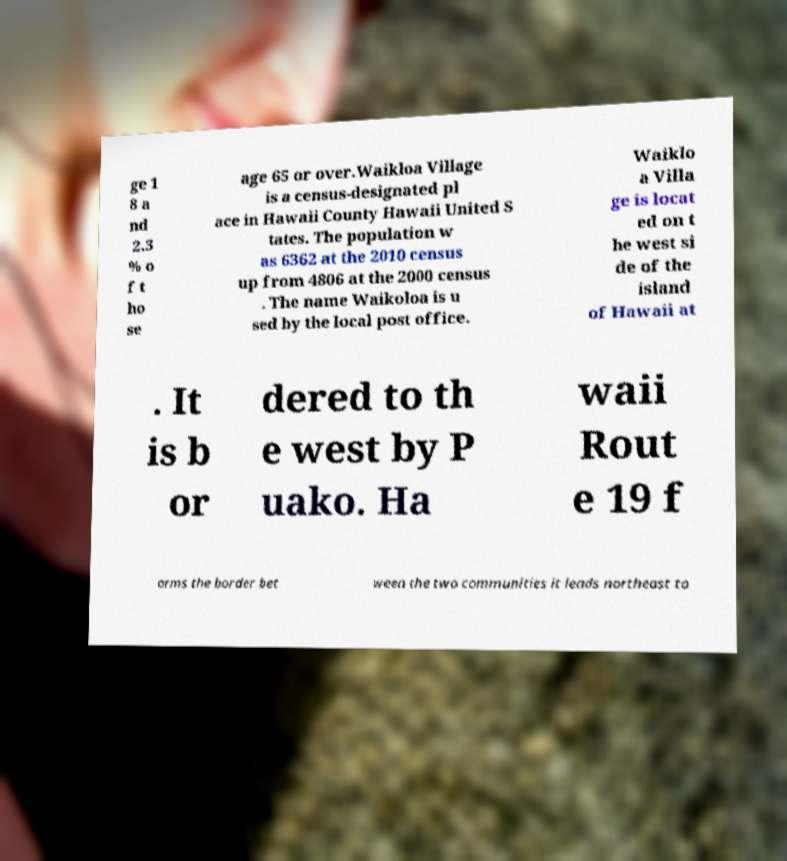Please read and relay the text visible in this image. What does it say? ge 1 8 a nd 2.3 % o f t ho se age 65 or over.Waikloa Village is a census-designated pl ace in Hawaii County Hawaii United S tates. The population w as 6362 at the 2010 census up from 4806 at the 2000 census . The name Waikoloa is u sed by the local post office. Waiklo a Villa ge is locat ed on t he west si de of the island of Hawaii at . It is b or dered to th e west by P uako. Ha waii Rout e 19 f orms the border bet ween the two communities it leads northeast to 